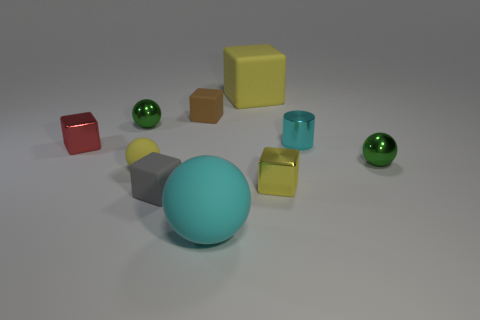Subtract all red metal cubes. How many cubes are left? 4 Subtract all brown blocks. How many blocks are left? 4 Subtract all green cubes. Subtract all yellow cylinders. How many cubes are left? 5 Subtract all cylinders. How many objects are left? 9 Subtract 0 blue spheres. How many objects are left? 10 Subtract all big yellow objects. Subtract all small green shiny things. How many objects are left? 7 Add 8 tiny cyan cylinders. How many tiny cyan cylinders are left? 9 Add 8 yellow blocks. How many yellow blocks exist? 10 